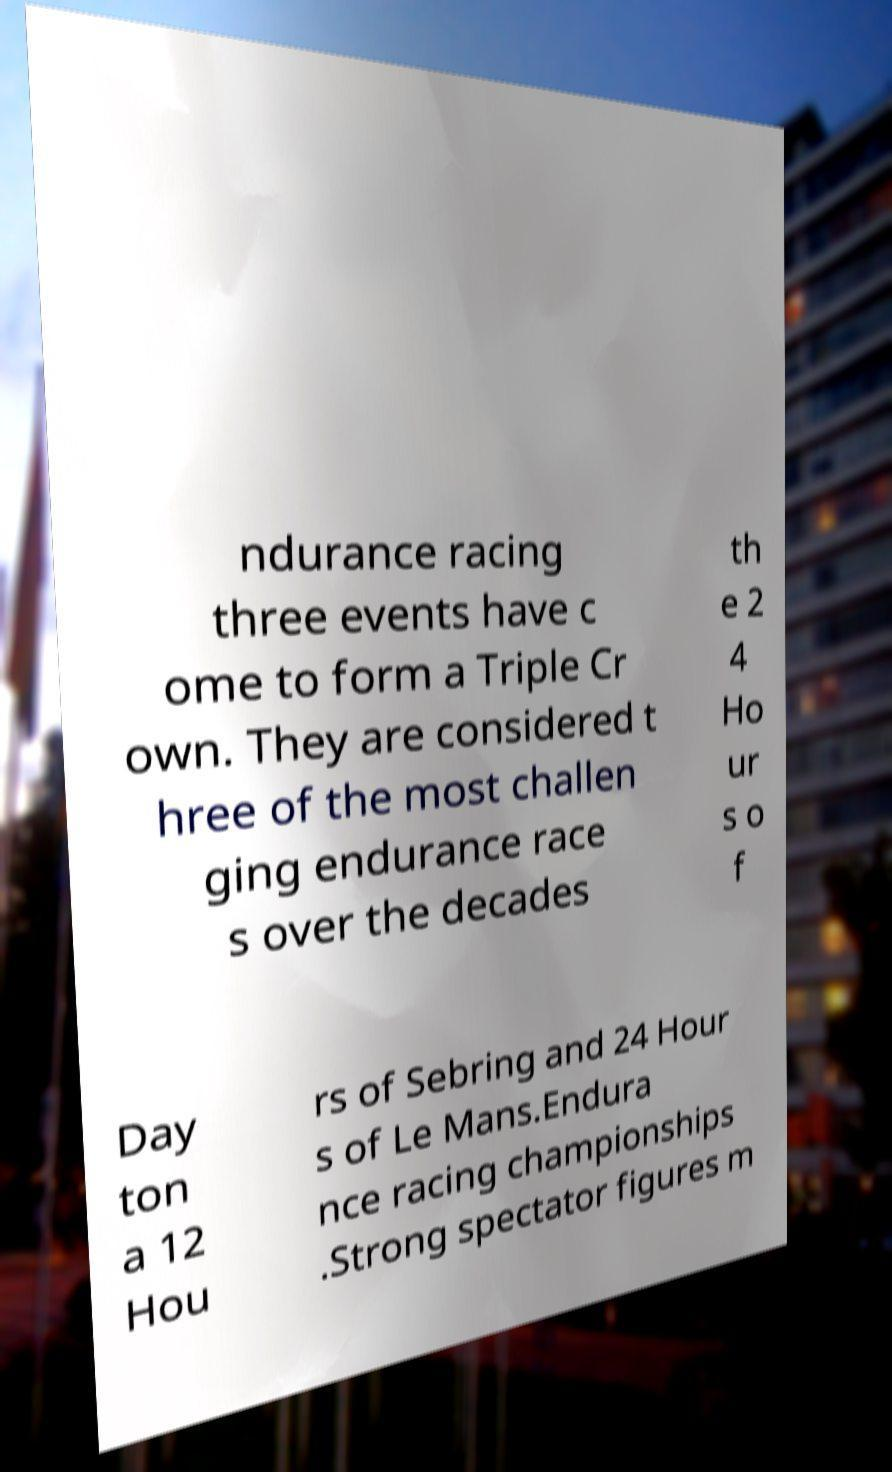Could you assist in decoding the text presented in this image and type it out clearly? ndurance racing three events have c ome to form a Triple Cr own. They are considered t hree of the most challen ging endurance race s over the decades th e 2 4 Ho ur s o f Day ton a 12 Hou rs of Sebring and 24 Hour s of Le Mans.Endura nce racing championships .Strong spectator figures m 